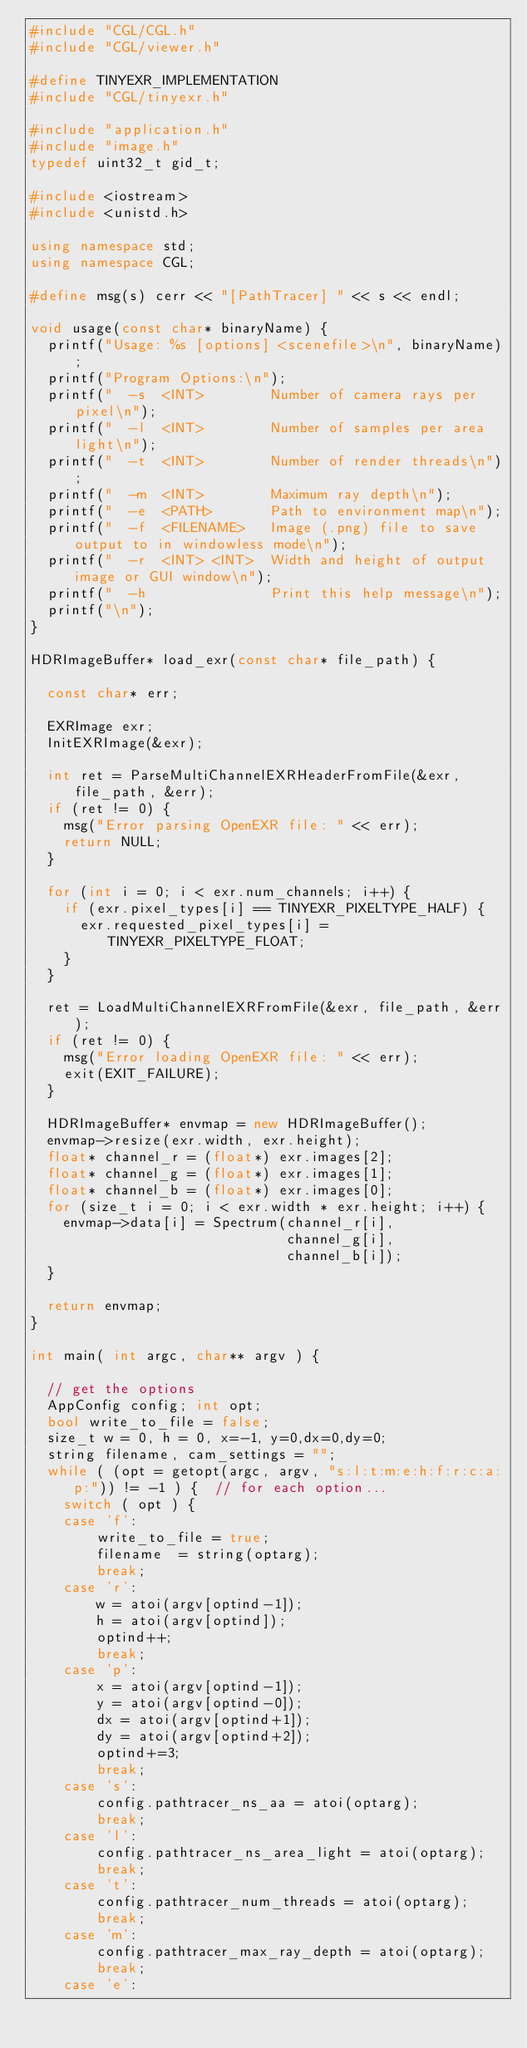<code> <loc_0><loc_0><loc_500><loc_500><_C++_>#include "CGL/CGL.h"
#include "CGL/viewer.h"

#define TINYEXR_IMPLEMENTATION
#include "CGL/tinyexr.h"

#include "application.h"
#include "image.h"
typedef uint32_t gid_t;

#include <iostream>
#include <unistd.h>

using namespace std;
using namespace CGL;

#define msg(s) cerr << "[PathTracer] " << s << endl;

void usage(const char* binaryName) {
  printf("Usage: %s [options] <scenefile>\n", binaryName);
  printf("Program Options:\n");
  printf("  -s  <INT>        Number of camera rays per pixel\n");
  printf("  -l  <INT>        Number of samples per area light\n");
  printf("  -t  <INT>        Number of render threads\n");
  printf("  -m  <INT>        Maximum ray depth\n");
  printf("  -e  <PATH>       Path to environment map\n");
  printf("  -f  <FILENAME>   Image (.png) file to save output to in windowless mode\n");
  printf("  -r  <INT> <INT>  Width and height of output image or GUI window\n");
  printf("  -h               Print this help message\n");
  printf("\n");
}

HDRImageBuffer* load_exr(const char* file_path) {
  
  const char* err;
  
  EXRImage exr;
  InitEXRImage(&exr);

  int ret = ParseMultiChannelEXRHeaderFromFile(&exr, file_path, &err);
  if (ret != 0) {
    msg("Error parsing OpenEXR file: " << err);
    return NULL;
  }

  for (int i = 0; i < exr.num_channels; i++) {
    if (exr.pixel_types[i] == TINYEXR_PIXELTYPE_HALF) {
      exr.requested_pixel_types[i] = TINYEXR_PIXELTYPE_FLOAT;
    }
  }

  ret = LoadMultiChannelEXRFromFile(&exr, file_path, &err);
  if (ret != 0) {
    msg("Error loading OpenEXR file: " << err);
    exit(EXIT_FAILURE);
  }

  HDRImageBuffer* envmap = new HDRImageBuffer();
  envmap->resize(exr.width, exr.height);
  float* channel_r = (float*) exr.images[2];
  float* channel_g = (float*) exr.images[1];
  float* channel_b = (float*) exr.images[0];
  for (size_t i = 0; i < exr.width * exr.height; i++) {
    envmap->data[i] = Spectrum(channel_r[i], 
                               channel_g[i], 
                               channel_b[i]);
  }

  return envmap;
}

int main( int argc, char** argv ) {

  // get the options
  AppConfig config; int opt;
  bool write_to_file = false;
  size_t w = 0, h = 0, x=-1, y=0,dx=0,dy=0;
  string filename, cam_settings = "";
  while ( (opt = getopt(argc, argv, "s:l:t:m:e:h:f:r:c:a:p:")) != -1 ) {  // for each option...
    switch ( opt ) {
    case 'f':
        write_to_file = true;
        filename  = string(optarg);
        break;
    case 'r':
        w = atoi(argv[optind-1]);
        h = atoi(argv[optind]);
        optind++;
        break;
    case 'p':
        x = atoi(argv[optind-1]);
        y = atoi(argv[optind-0]);
        dx = atoi(argv[optind+1]);
        dy = atoi(argv[optind+2]);
        optind+=3;
        break;
    case 's':
        config.pathtracer_ns_aa = atoi(optarg);
        break;
    case 'l':
        config.pathtracer_ns_area_light = atoi(optarg);
        break;
    case 't':
        config.pathtracer_num_threads = atoi(optarg);
        break;
    case 'm':
        config.pathtracer_max_ray_depth = atoi(optarg);
        break;
    case 'e':</code> 